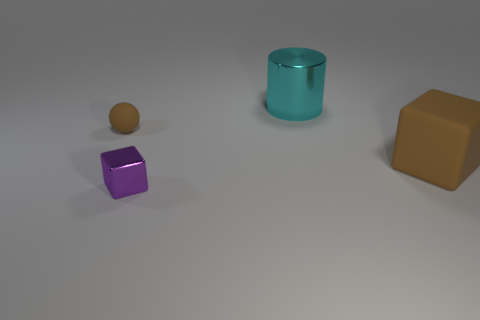What is the material of the large cyan cylinder behind the tiny shiny block?
Ensure brevity in your answer.  Metal. Are there any other shiny things of the same color as the large shiny thing?
Give a very brief answer. No. There is a brown object that is the same size as the purple metal block; what is its shape?
Provide a succinct answer. Sphere. What is the color of the large thing to the left of the big brown cube?
Offer a very short reply. Cyan. Are there any matte objects behind the tiny thing that is behind the metal cube?
Make the answer very short. No. What number of things are either brown spheres that are in front of the cylinder or tiny brown things?
Provide a succinct answer. 1. Are there any other things that have the same size as the metal block?
Offer a terse response. Yes. What is the material of the big thing to the right of the shiny thing that is to the right of the purple metallic cube?
Your answer should be very brief. Rubber. Are there an equal number of tiny metal objects on the left side of the brown matte sphere and brown matte objects on the right side of the cyan object?
Your answer should be compact. No. How many things are cubes behind the small purple thing or shiny objects that are in front of the large cylinder?
Provide a short and direct response. 2. 